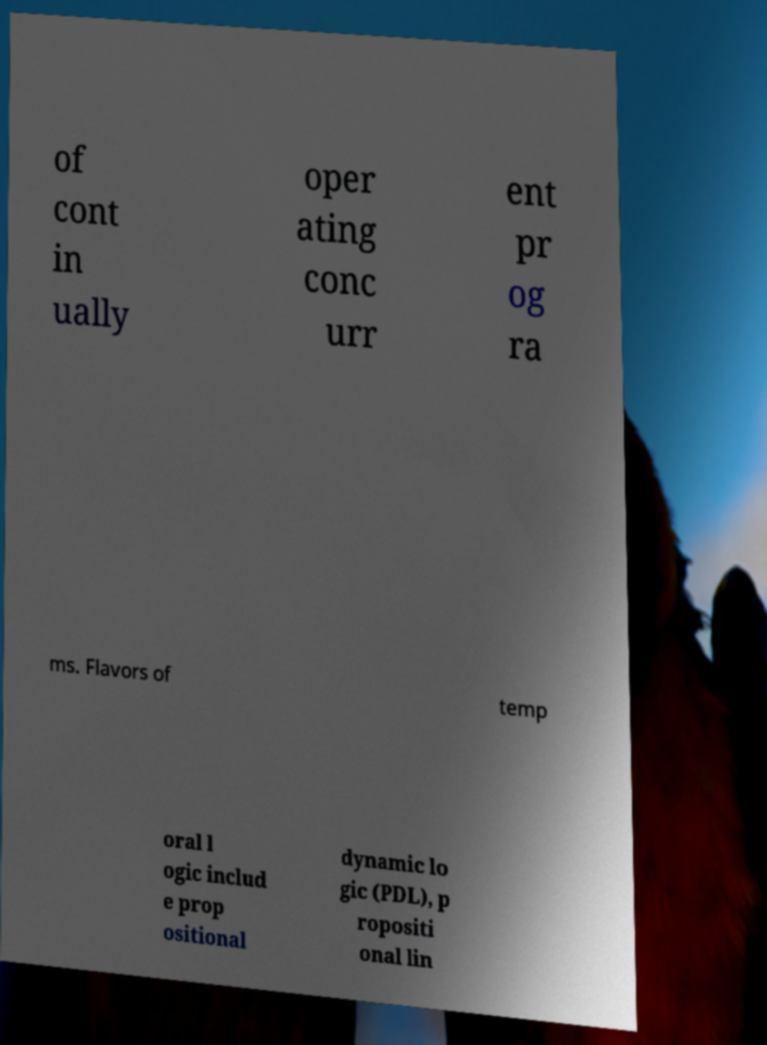Can you accurately transcribe the text from the provided image for me? of cont in ually oper ating conc urr ent pr og ra ms. Flavors of temp oral l ogic includ e prop ositional dynamic lo gic (PDL), p ropositi onal lin 